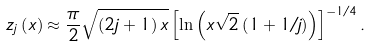<formula> <loc_0><loc_0><loc_500><loc_500>z _ { j } \left ( x \right ) \approx \frac { \pi } { 2 } \sqrt { \left ( 2 j + 1 \right ) x } \left [ \ln \left ( x \sqrt { 2 } \left ( 1 + 1 / j \right ) \right ) \right ] ^ { - 1 / 4 } .</formula> 